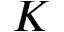Convert formula to latex. <formula><loc_0><loc_0><loc_500><loc_500>K</formula> 